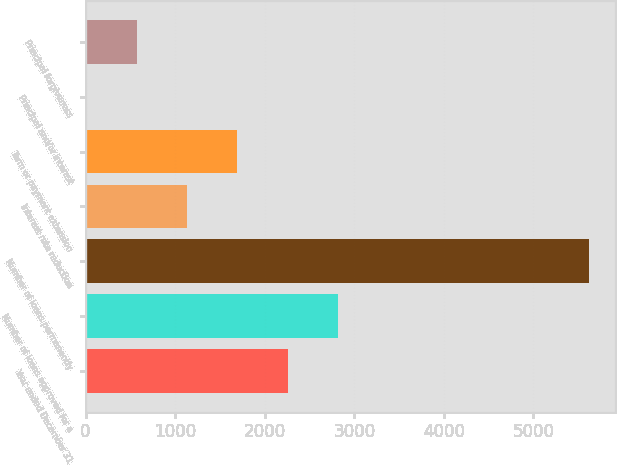Convert chart to OTSL. <chart><loc_0><loc_0><loc_500><loc_500><bar_chart><fcel>Year ended December 31<fcel>Number of loans approved for a<fcel>Number of loans permanently<fcel>Interest rate reduction<fcel>Term or payment extension<fcel>Principal and/or interest<fcel>Principal forgiveness<nl><fcel>2255.6<fcel>2817<fcel>5624<fcel>1132.8<fcel>1694.2<fcel>10<fcel>571.4<nl></chart> 